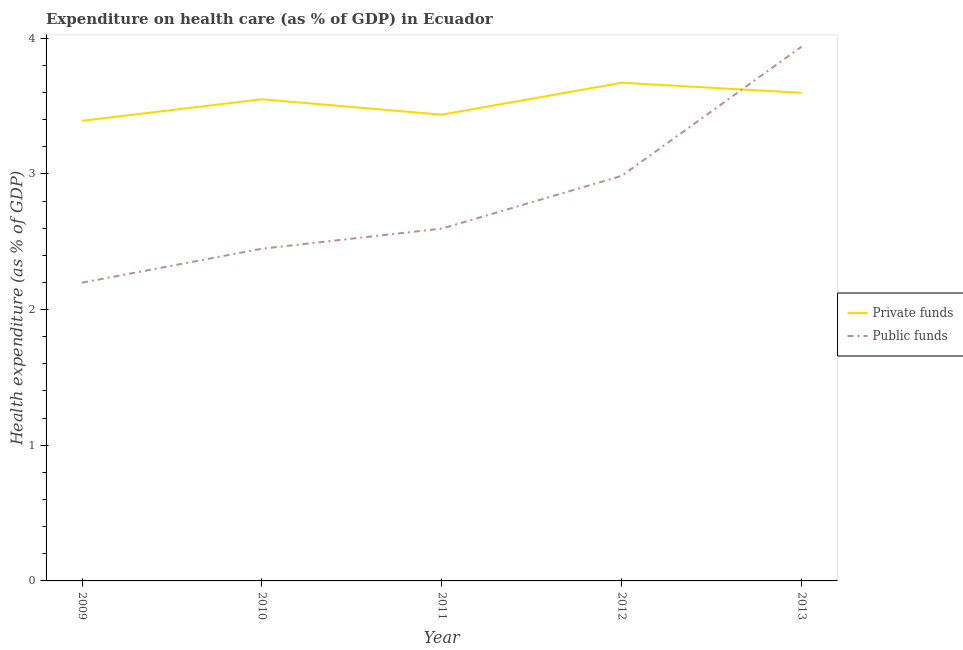How many different coloured lines are there?
Your answer should be very brief. 2. What is the amount of private funds spent in healthcare in 2011?
Your answer should be very brief. 3.44. Across all years, what is the maximum amount of public funds spent in healthcare?
Provide a succinct answer. 3.94. Across all years, what is the minimum amount of private funds spent in healthcare?
Your answer should be compact. 3.39. In which year was the amount of public funds spent in healthcare minimum?
Give a very brief answer. 2009. What is the total amount of public funds spent in healthcare in the graph?
Provide a short and direct response. 14.17. What is the difference between the amount of private funds spent in healthcare in 2011 and that in 2012?
Your answer should be compact. -0.24. What is the difference between the amount of private funds spent in healthcare in 2013 and the amount of public funds spent in healthcare in 2010?
Your response must be concise. 1.15. What is the average amount of private funds spent in healthcare per year?
Make the answer very short. 3.53. In the year 2009, what is the difference between the amount of public funds spent in healthcare and amount of private funds spent in healthcare?
Keep it short and to the point. -1.19. In how many years, is the amount of public funds spent in healthcare greater than 0.2 %?
Offer a very short reply. 5. What is the ratio of the amount of private funds spent in healthcare in 2009 to that in 2012?
Offer a terse response. 0.92. Is the amount of public funds spent in healthcare in 2012 less than that in 2013?
Offer a terse response. Yes. What is the difference between the highest and the second highest amount of private funds spent in healthcare?
Your answer should be very brief. 0.07. What is the difference between the highest and the lowest amount of private funds spent in healthcare?
Provide a succinct answer. 0.28. In how many years, is the amount of public funds spent in healthcare greater than the average amount of public funds spent in healthcare taken over all years?
Your answer should be very brief. 2. Is the sum of the amount of public funds spent in healthcare in 2012 and 2013 greater than the maximum amount of private funds spent in healthcare across all years?
Keep it short and to the point. Yes. Does the amount of public funds spent in healthcare monotonically increase over the years?
Your answer should be very brief. Yes. Is the amount of private funds spent in healthcare strictly greater than the amount of public funds spent in healthcare over the years?
Keep it short and to the point. No. How many lines are there?
Offer a terse response. 2. How many years are there in the graph?
Make the answer very short. 5. What is the difference between two consecutive major ticks on the Y-axis?
Make the answer very short. 1. Are the values on the major ticks of Y-axis written in scientific E-notation?
Keep it short and to the point. No. Does the graph contain any zero values?
Provide a short and direct response. No. Does the graph contain grids?
Your answer should be compact. No. Where does the legend appear in the graph?
Offer a terse response. Center right. How many legend labels are there?
Ensure brevity in your answer.  2. How are the legend labels stacked?
Provide a short and direct response. Vertical. What is the title of the graph?
Provide a short and direct response. Expenditure on health care (as % of GDP) in Ecuador. Does "Largest city" appear as one of the legend labels in the graph?
Provide a succinct answer. No. What is the label or title of the Y-axis?
Make the answer very short. Health expenditure (as % of GDP). What is the Health expenditure (as % of GDP) of Private funds in 2009?
Give a very brief answer. 3.39. What is the Health expenditure (as % of GDP) in Public funds in 2009?
Provide a succinct answer. 2.2. What is the Health expenditure (as % of GDP) of Private funds in 2010?
Offer a very short reply. 3.55. What is the Health expenditure (as % of GDP) of Public funds in 2010?
Offer a very short reply. 2.45. What is the Health expenditure (as % of GDP) of Private funds in 2011?
Offer a very short reply. 3.44. What is the Health expenditure (as % of GDP) in Public funds in 2011?
Make the answer very short. 2.6. What is the Health expenditure (as % of GDP) of Private funds in 2012?
Your response must be concise. 3.67. What is the Health expenditure (as % of GDP) in Public funds in 2012?
Provide a succinct answer. 2.99. What is the Health expenditure (as % of GDP) of Private funds in 2013?
Make the answer very short. 3.6. What is the Health expenditure (as % of GDP) in Public funds in 2013?
Your answer should be very brief. 3.94. Across all years, what is the maximum Health expenditure (as % of GDP) of Private funds?
Offer a very short reply. 3.67. Across all years, what is the maximum Health expenditure (as % of GDP) in Public funds?
Ensure brevity in your answer.  3.94. Across all years, what is the minimum Health expenditure (as % of GDP) in Private funds?
Provide a short and direct response. 3.39. Across all years, what is the minimum Health expenditure (as % of GDP) in Public funds?
Your answer should be very brief. 2.2. What is the total Health expenditure (as % of GDP) of Private funds in the graph?
Provide a succinct answer. 17.65. What is the total Health expenditure (as % of GDP) of Public funds in the graph?
Make the answer very short. 14.17. What is the difference between the Health expenditure (as % of GDP) of Private funds in 2009 and that in 2010?
Your answer should be very brief. -0.16. What is the difference between the Health expenditure (as % of GDP) in Public funds in 2009 and that in 2010?
Provide a short and direct response. -0.25. What is the difference between the Health expenditure (as % of GDP) of Private funds in 2009 and that in 2011?
Offer a terse response. -0.05. What is the difference between the Health expenditure (as % of GDP) of Public funds in 2009 and that in 2011?
Provide a short and direct response. -0.4. What is the difference between the Health expenditure (as % of GDP) of Private funds in 2009 and that in 2012?
Ensure brevity in your answer.  -0.28. What is the difference between the Health expenditure (as % of GDP) of Public funds in 2009 and that in 2012?
Provide a succinct answer. -0.79. What is the difference between the Health expenditure (as % of GDP) in Private funds in 2009 and that in 2013?
Your answer should be compact. -0.21. What is the difference between the Health expenditure (as % of GDP) in Public funds in 2009 and that in 2013?
Provide a succinct answer. -1.74. What is the difference between the Health expenditure (as % of GDP) in Private funds in 2010 and that in 2011?
Offer a terse response. 0.11. What is the difference between the Health expenditure (as % of GDP) in Public funds in 2010 and that in 2011?
Provide a short and direct response. -0.15. What is the difference between the Health expenditure (as % of GDP) of Private funds in 2010 and that in 2012?
Offer a very short reply. -0.12. What is the difference between the Health expenditure (as % of GDP) of Public funds in 2010 and that in 2012?
Provide a short and direct response. -0.54. What is the difference between the Health expenditure (as % of GDP) of Private funds in 2010 and that in 2013?
Your answer should be compact. -0.05. What is the difference between the Health expenditure (as % of GDP) of Public funds in 2010 and that in 2013?
Keep it short and to the point. -1.49. What is the difference between the Health expenditure (as % of GDP) of Private funds in 2011 and that in 2012?
Ensure brevity in your answer.  -0.24. What is the difference between the Health expenditure (as % of GDP) in Public funds in 2011 and that in 2012?
Make the answer very short. -0.39. What is the difference between the Health expenditure (as % of GDP) in Private funds in 2011 and that in 2013?
Provide a short and direct response. -0.16. What is the difference between the Health expenditure (as % of GDP) of Public funds in 2011 and that in 2013?
Keep it short and to the point. -1.34. What is the difference between the Health expenditure (as % of GDP) in Private funds in 2012 and that in 2013?
Provide a succinct answer. 0.07. What is the difference between the Health expenditure (as % of GDP) of Public funds in 2012 and that in 2013?
Offer a very short reply. -0.95. What is the difference between the Health expenditure (as % of GDP) of Private funds in 2009 and the Health expenditure (as % of GDP) of Public funds in 2010?
Your answer should be very brief. 0.94. What is the difference between the Health expenditure (as % of GDP) of Private funds in 2009 and the Health expenditure (as % of GDP) of Public funds in 2011?
Ensure brevity in your answer.  0.79. What is the difference between the Health expenditure (as % of GDP) of Private funds in 2009 and the Health expenditure (as % of GDP) of Public funds in 2012?
Ensure brevity in your answer.  0.41. What is the difference between the Health expenditure (as % of GDP) in Private funds in 2009 and the Health expenditure (as % of GDP) in Public funds in 2013?
Your answer should be very brief. -0.55. What is the difference between the Health expenditure (as % of GDP) in Private funds in 2010 and the Health expenditure (as % of GDP) in Public funds in 2011?
Provide a short and direct response. 0.95. What is the difference between the Health expenditure (as % of GDP) of Private funds in 2010 and the Health expenditure (as % of GDP) of Public funds in 2012?
Provide a succinct answer. 0.56. What is the difference between the Health expenditure (as % of GDP) of Private funds in 2010 and the Health expenditure (as % of GDP) of Public funds in 2013?
Offer a very short reply. -0.39. What is the difference between the Health expenditure (as % of GDP) in Private funds in 2011 and the Health expenditure (as % of GDP) in Public funds in 2012?
Provide a succinct answer. 0.45. What is the difference between the Health expenditure (as % of GDP) of Private funds in 2011 and the Health expenditure (as % of GDP) of Public funds in 2013?
Provide a succinct answer. -0.5. What is the difference between the Health expenditure (as % of GDP) in Private funds in 2012 and the Health expenditure (as % of GDP) in Public funds in 2013?
Keep it short and to the point. -0.27. What is the average Health expenditure (as % of GDP) of Private funds per year?
Ensure brevity in your answer.  3.53. What is the average Health expenditure (as % of GDP) in Public funds per year?
Offer a very short reply. 2.83. In the year 2009, what is the difference between the Health expenditure (as % of GDP) of Private funds and Health expenditure (as % of GDP) of Public funds?
Provide a short and direct response. 1.19. In the year 2010, what is the difference between the Health expenditure (as % of GDP) in Private funds and Health expenditure (as % of GDP) in Public funds?
Keep it short and to the point. 1.1. In the year 2011, what is the difference between the Health expenditure (as % of GDP) of Private funds and Health expenditure (as % of GDP) of Public funds?
Give a very brief answer. 0.84. In the year 2012, what is the difference between the Health expenditure (as % of GDP) of Private funds and Health expenditure (as % of GDP) of Public funds?
Offer a very short reply. 0.69. In the year 2013, what is the difference between the Health expenditure (as % of GDP) of Private funds and Health expenditure (as % of GDP) of Public funds?
Offer a very short reply. -0.34. What is the ratio of the Health expenditure (as % of GDP) in Private funds in 2009 to that in 2010?
Offer a very short reply. 0.96. What is the ratio of the Health expenditure (as % of GDP) in Public funds in 2009 to that in 2010?
Provide a succinct answer. 0.9. What is the ratio of the Health expenditure (as % of GDP) in Private funds in 2009 to that in 2011?
Keep it short and to the point. 0.99. What is the ratio of the Health expenditure (as % of GDP) in Public funds in 2009 to that in 2011?
Give a very brief answer. 0.85. What is the ratio of the Health expenditure (as % of GDP) of Private funds in 2009 to that in 2012?
Your answer should be compact. 0.92. What is the ratio of the Health expenditure (as % of GDP) of Public funds in 2009 to that in 2012?
Ensure brevity in your answer.  0.74. What is the ratio of the Health expenditure (as % of GDP) of Private funds in 2009 to that in 2013?
Your response must be concise. 0.94. What is the ratio of the Health expenditure (as % of GDP) of Public funds in 2009 to that in 2013?
Offer a terse response. 0.56. What is the ratio of the Health expenditure (as % of GDP) in Private funds in 2010 to that in 2011?
Your response must be concise. 1.03. What is the ratio of the Health expenditure (as % of GDP) in Public funds in 2010 to that in 2011?
Your answer should be compact. 0.94. What is the ratio of the Health expenditure (as % of GDP) of Private funds in 2010 to that in 2012?
Ensure brevity in your answer.  0.97. What is the ratio of the Health expenditure (as % of GDP) of Public funds in 2010 to that in 2012?
Offer a terse response. 0.82. What is the ratio of the Health expenditure (as % of GDP) of Private funds in 2010 to that in 2013?
Keep it short and to the point. 0.99. What is the ratio of the Health expenditure (as % of GDP) in Public funds in 2010 to that in 2013?
Give a very brief answer. 0.62. What is the ratio of the Health expenditure (as % of GDP) in Private funds in 2011 to that in 2012?
Give a very brief answer. 0.94. What is the ratio of the Health expenditure (as % of GDP) in Public funds in 2011 to that in 2012?
Make the answer very short. 0.87. What is the ratio of the Health expenditure (as % of GDP) of Private funds in 2011 to that in 2013?
Make the answer very short. 0.96. What is the ratio of the Health expenditure (as % of GDP) of Public funds in 2011 to that in 2013?
Your response must be concise. 0.66. What is the ratio of the Health expenditure (as % of GDP) of Private funds in 2012 to that in 2013?
Your answer should be compact. 1.02. What is the ratio of the Health expenditure (as % of GDP) in Public funds in 2012 to that in 2013?
Keep it short and to the point. 0.76. What is the difference between the highest and the second highest Health expenditure (as % of GDP) in Private funds?
Make the answer very short. 0.07. What is the difference between the highest and the second highest Health expenditure (as % of GDP) of Public funds?
Your answer should be very brief. 0.95. What is the difference between the highest and the lowest Health expenditure (as % of GDP) of Private funds?
Keep it short and to the point. 0.28. What is the difference between the highest and the lowest Health expenditure (as % of GDP) of Public funds?
Your answer should be compact. 1.74. 